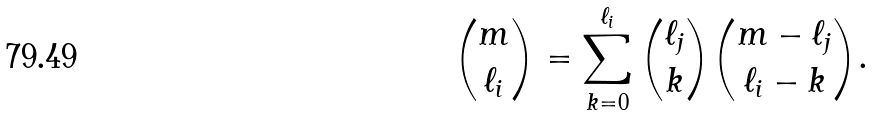Convert formula to latex. <formula><loc_0><loc_0><loc_500><loc_500>\binom { m } { \ell _ { i } } = \sum _ { k = 0 } ^ { \ell _ { i } } \binom { \ell _ { j } } { k } \binom { m - \ell _ { j } } { \ell _ { i } - k } .</formula> 